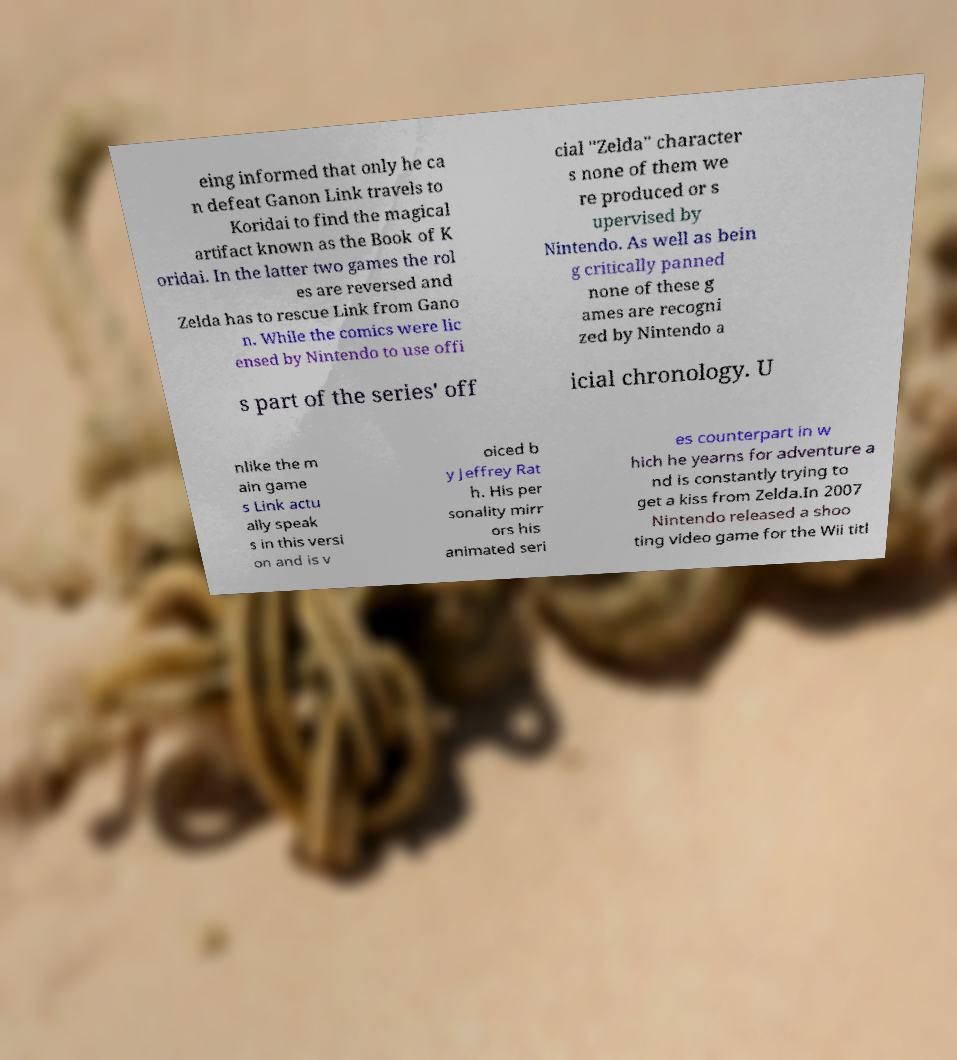Could you extract and type out the text from this image? eing informed that only he ca n defeat Ganon Link travels to Koridai to find the magical artifact known as the Book of K oridai. In the latter two games the rol es are reversed and Zelda has to rescue Link from Gano n. While the comics were lic ensed by Nintendo to use offi cial "Zelda" character s none of them we re produced or s upervised by Nintendo. As well as bein g critically panned none of these g ames are recogni zed by Nintendo a s part of the series' off icial chronology. U nlike the m ain game s Link actu ally speak s in this versi on and is v oiced b y Jeffrey Rat h. His per sonality mirr ors his animated seri es counterpart in w hich he yearns for adventure a nd is constantly trying to get a kiss from Zelda.In 2007 Nintendo released a shoo ting video game for the Wii titl 